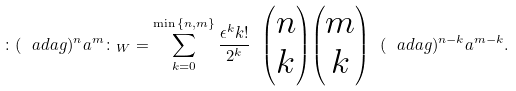<formula> <loc_0><loc_0><loc_500><loc_500>\colon ( \ a d a g ) ^ { n } a ^ { m } \colon _ { W } = \sum _ { k = 0 } ^ { \min { \{ n , m \} } } \frac { \epsilon ^ { k } k ! } { 2 ^ { k } } \ { \begin{pmatrix} n \\ k \end{pmatrix} } { \begin{pmatrix} m \\ k \end{pmatrix} } \ ( \ a d a g ) ^ { n - k } a ^ { m - k } .</formula> 